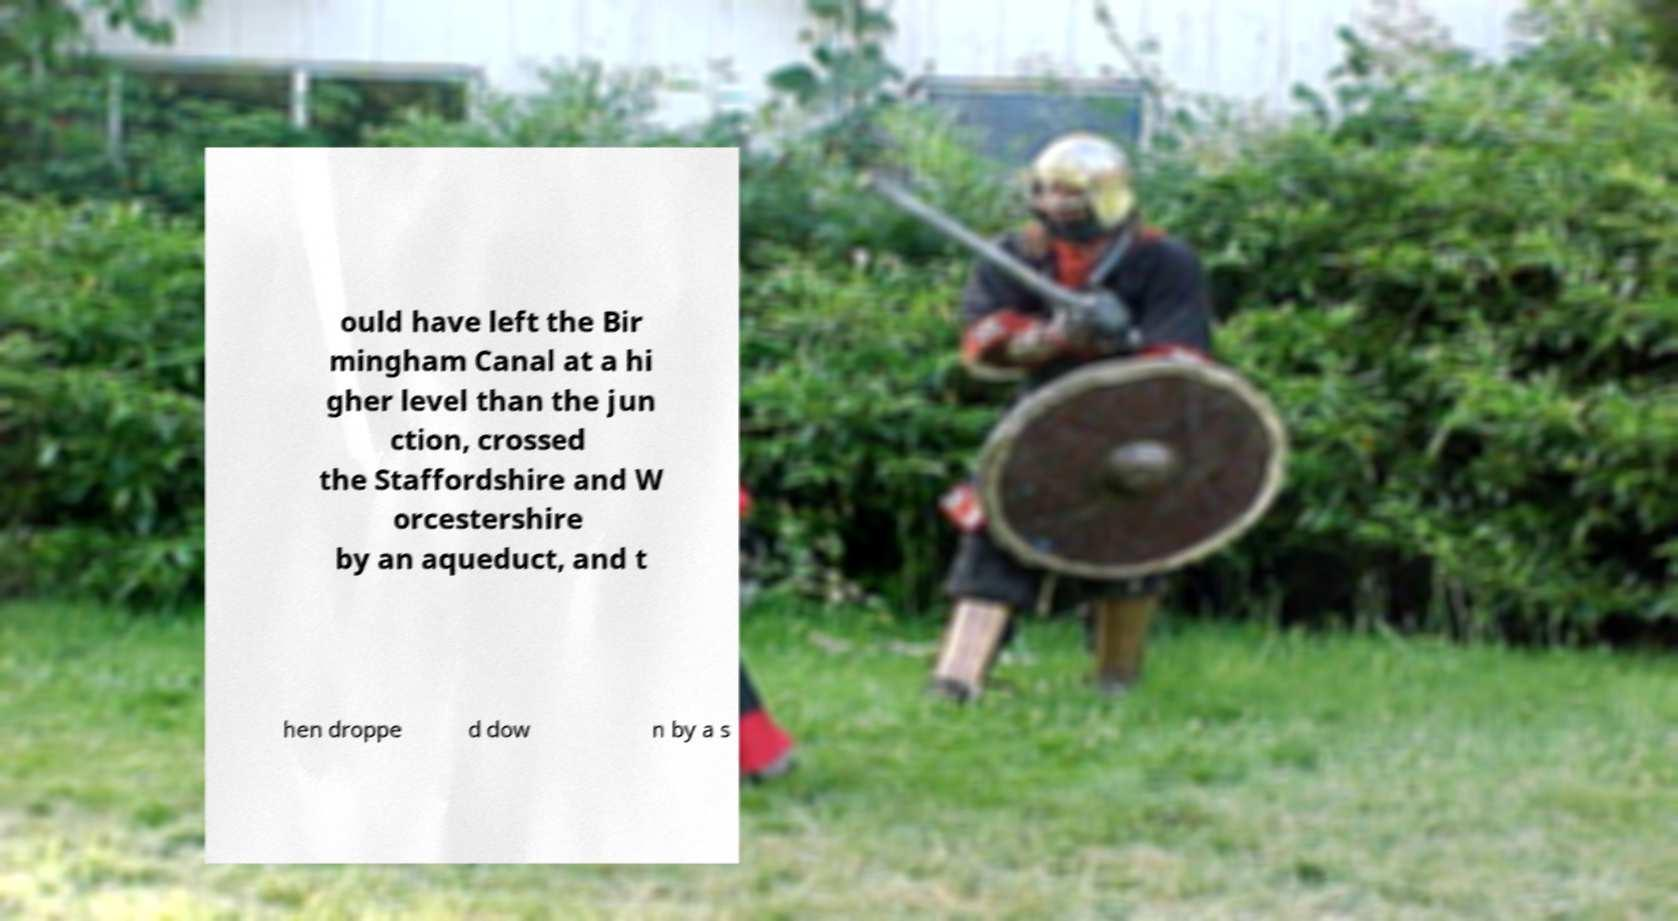Please identify and transcribe the text found in this image. ould have left the Bir mingham Canal at a hi gher level than the jun ction, crossed the Staffordshire and W orcestershire by an aqueduct, and t hen droppe d dow n by a s 